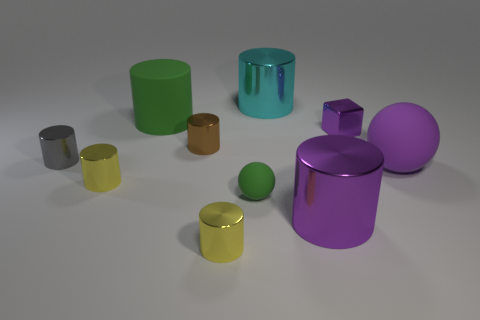Do the matte thing that is to the right of the small purple cube and the rubber thing that is to the left of the small green matte sphere have the same color?
Provide a succinct answer. No. What is the shape of the yellow object that is in front of the cylinder that is on the right side of the large cyan cylinder?
Your response must be concise. Cylinder. Is there a yellow cylinder that has the same size as the purple metal cylinder?
Ensure brevity in your answer.  No. How many big green matte objects have the same shape as the tiny matte thing?
Your answer should be compact. 0. Are there the same number of green rubber cylinders that are in front of the large purple cylinder and shiny objects to the left of the large cyan thing?
Keep it short and to the point. No. Are any small cyan shiny things visible?
Offer a terse response. No. How big is the matte sphere on the left side of the small purple block behind the tiny cylinder behind the gray object?
Offer a very short reply. Small. There is a green rubber thing that is the same size as the brown object; what is its shape?
Your answer should be very brief. Sphere. Are there any other things that have the same material as the big purple cylinder?
Provide a succinct answer. Yes. How many objects are large metallic cylinders that are to the right of the cyan metallic object or green shiny cubes?
Provide a succinct answer. 1. 